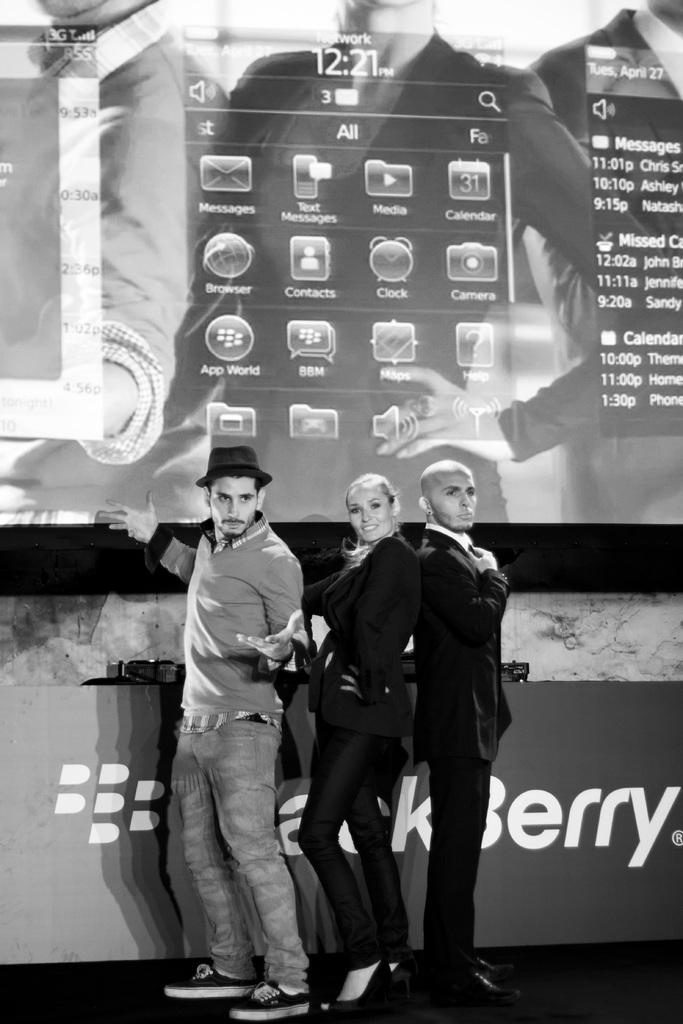What are the people in the image doing? The people in the image are standing on the ground. What can be seen in the background of the image? There is a screen, a wall, an advertisement board, and other objects visible in the background of the image. What type of crime is being committed in the image? There is no indication of any crime being committed in the image. Can you tell me what kind of cork is being used to hold up the advertisement board? There is no cork visible in the image, and the advertisement board is not being held up by any visible means. 